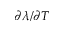<formula> <loc_0><loc_0><loc_500><loc_500>\partial \lambda / \partial T</formula> 